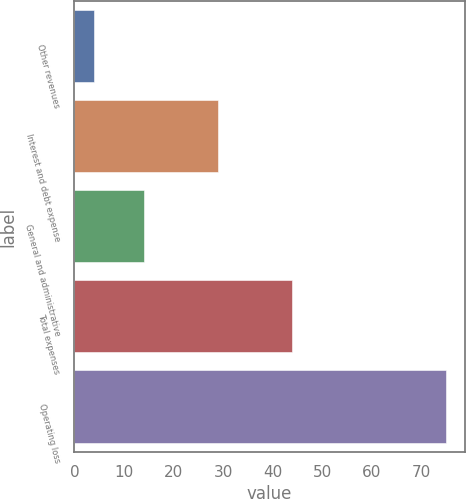<chart> <loc_0><loc_0><loc_500><loc_500><bar_chart><fcel>Other revenues<fcel>Interest and debt expense<fcel>General and administrative<fcel>Total expenses<fcel>Operating loss<nl><fcel>4<fcel>29<fcel>14<fcel>44<fcel>75<nl></chart> 